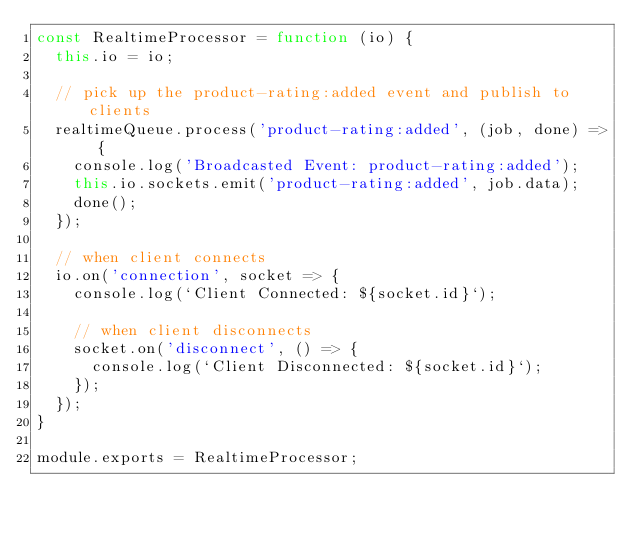Convert code to text. <code><loc_0><loc_0><loc_500><loc_500><_JavaScript_>const RealtimeProcessor = function (io) {
  this.io = io;

  // pick up the product-rating:added event and publish to clients
  realtimeQueue.process('product-rating:added', (job, done) => {
    console.log('Broadcasted Event: product-rating:added');
    this.io.sockets.emit('product-rating:added', job.data);
    done();
  });

  // when client connects
  io.on('connection', socket => {
    console.log(`Client Connected: ${socket.id}`);

    // when client disconnects
    socket.on('disconnect', () => {
      console.log(`Client Disconnected: ${socket.id}`);
    });
  });
}

module.exports = RealtimeProcessor;</code> 